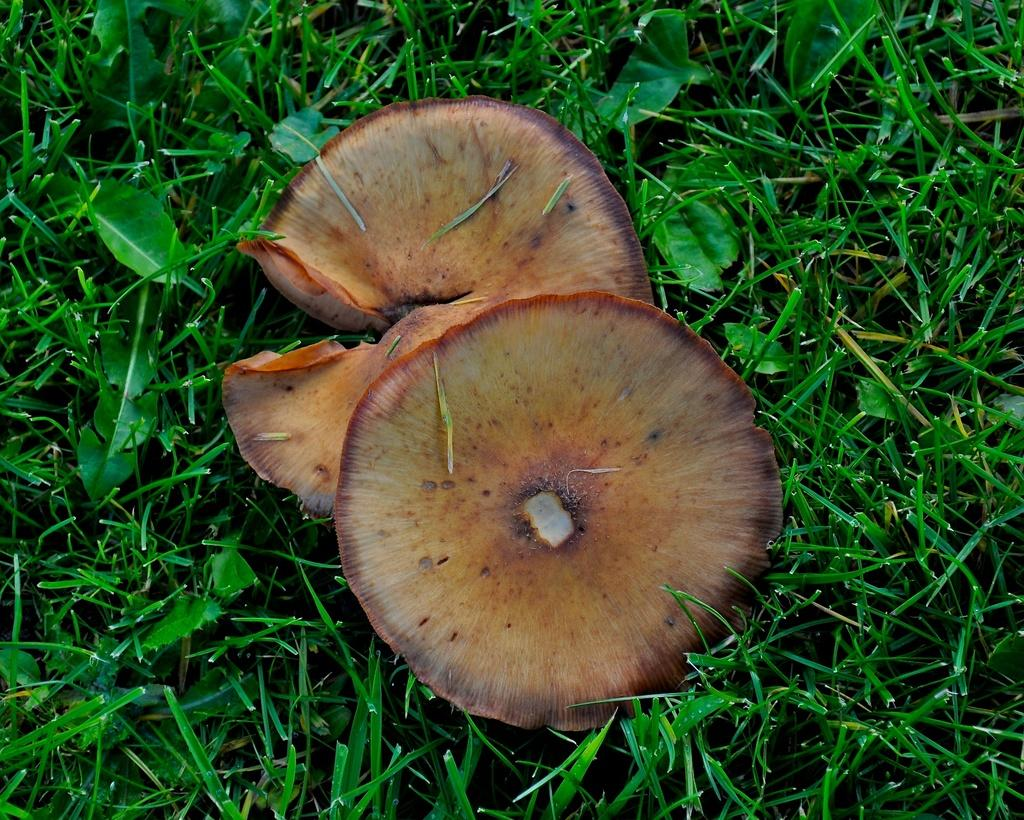How many mushrooms are present in the image? There are two mushrooms in the image. What type of vegetation is visible at the bottom of the image? There is grass at the bottom of the image. What color is the sister's sweater in the image? There is no sister or sweater present in the image. 